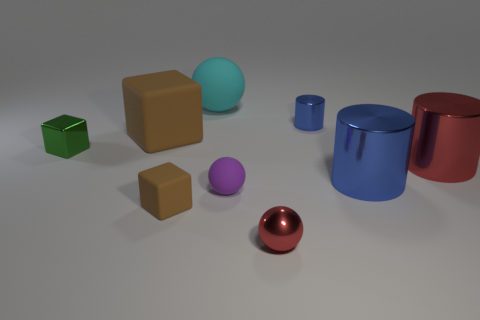Can you describe the lighting in the scene? Certainly! The lighting in the scene seems to be diffused, with soft shadows cast underneath the objects, indicating a light source that is not too harsh or direct, providing an even illumination across the entire scene. 